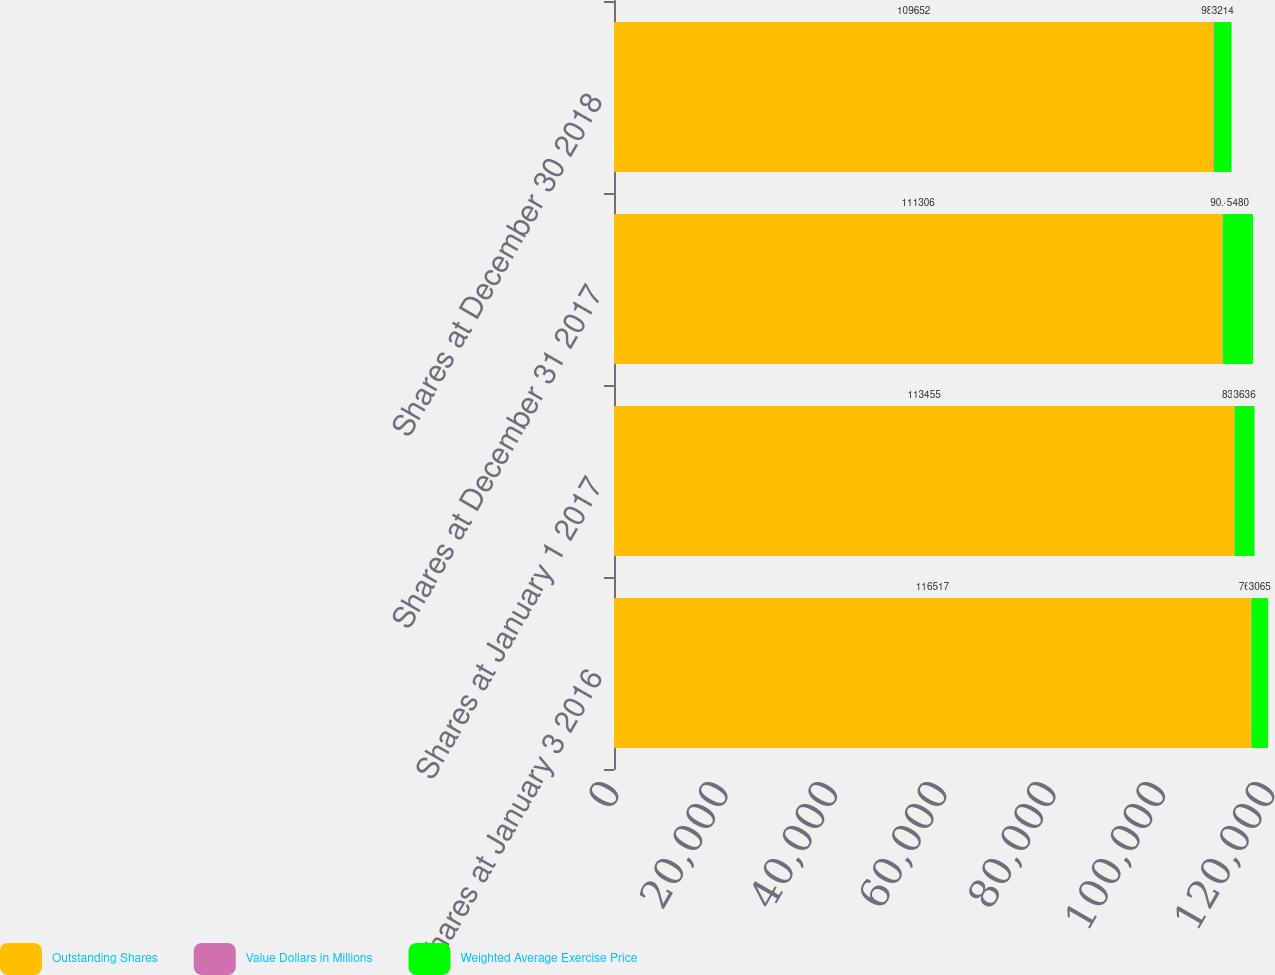Convert chart to OTSL. <chart><loc_0><loc_0><loc_500><loc_500><stacked_bar_chart><ecel><fcel>Shares at January 3 2016<fcel>Shares at January 1 2017<fcel>Shares at December 31 2017<fcel>Shares at December 30 2018<nl><fcel>Outstanding Shares<fcel>116517<fcel>113455<fcel>111306<fcel>109652<nl><fcel>Value Dollars in Millions<fcel>76.41<fcel>83.16<fcel>90.48<fcel>98.29<nl><fcel>Weighted Average Exercise Price<fcel>3065<fcel>3636<fcel>5480<fcel>3214<nl></chart> 